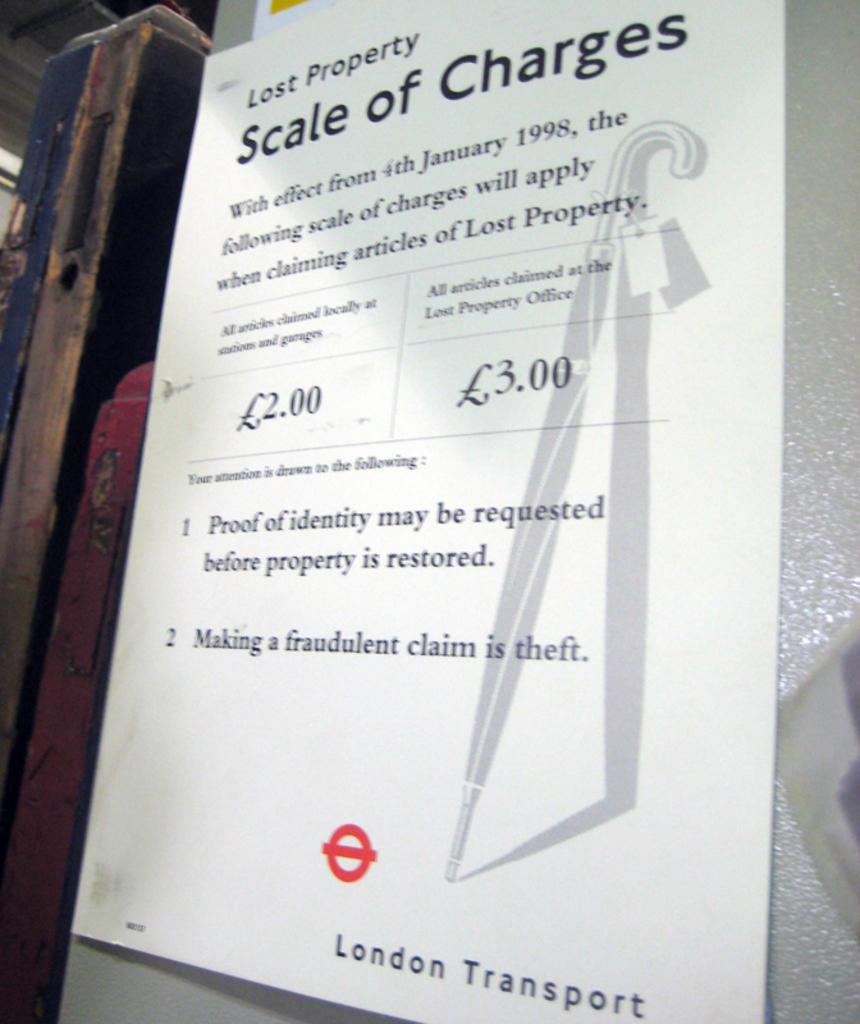<image>
Write a terse but informative summary of the picture. Lost property scale of charges paper is posted for the London Transport 